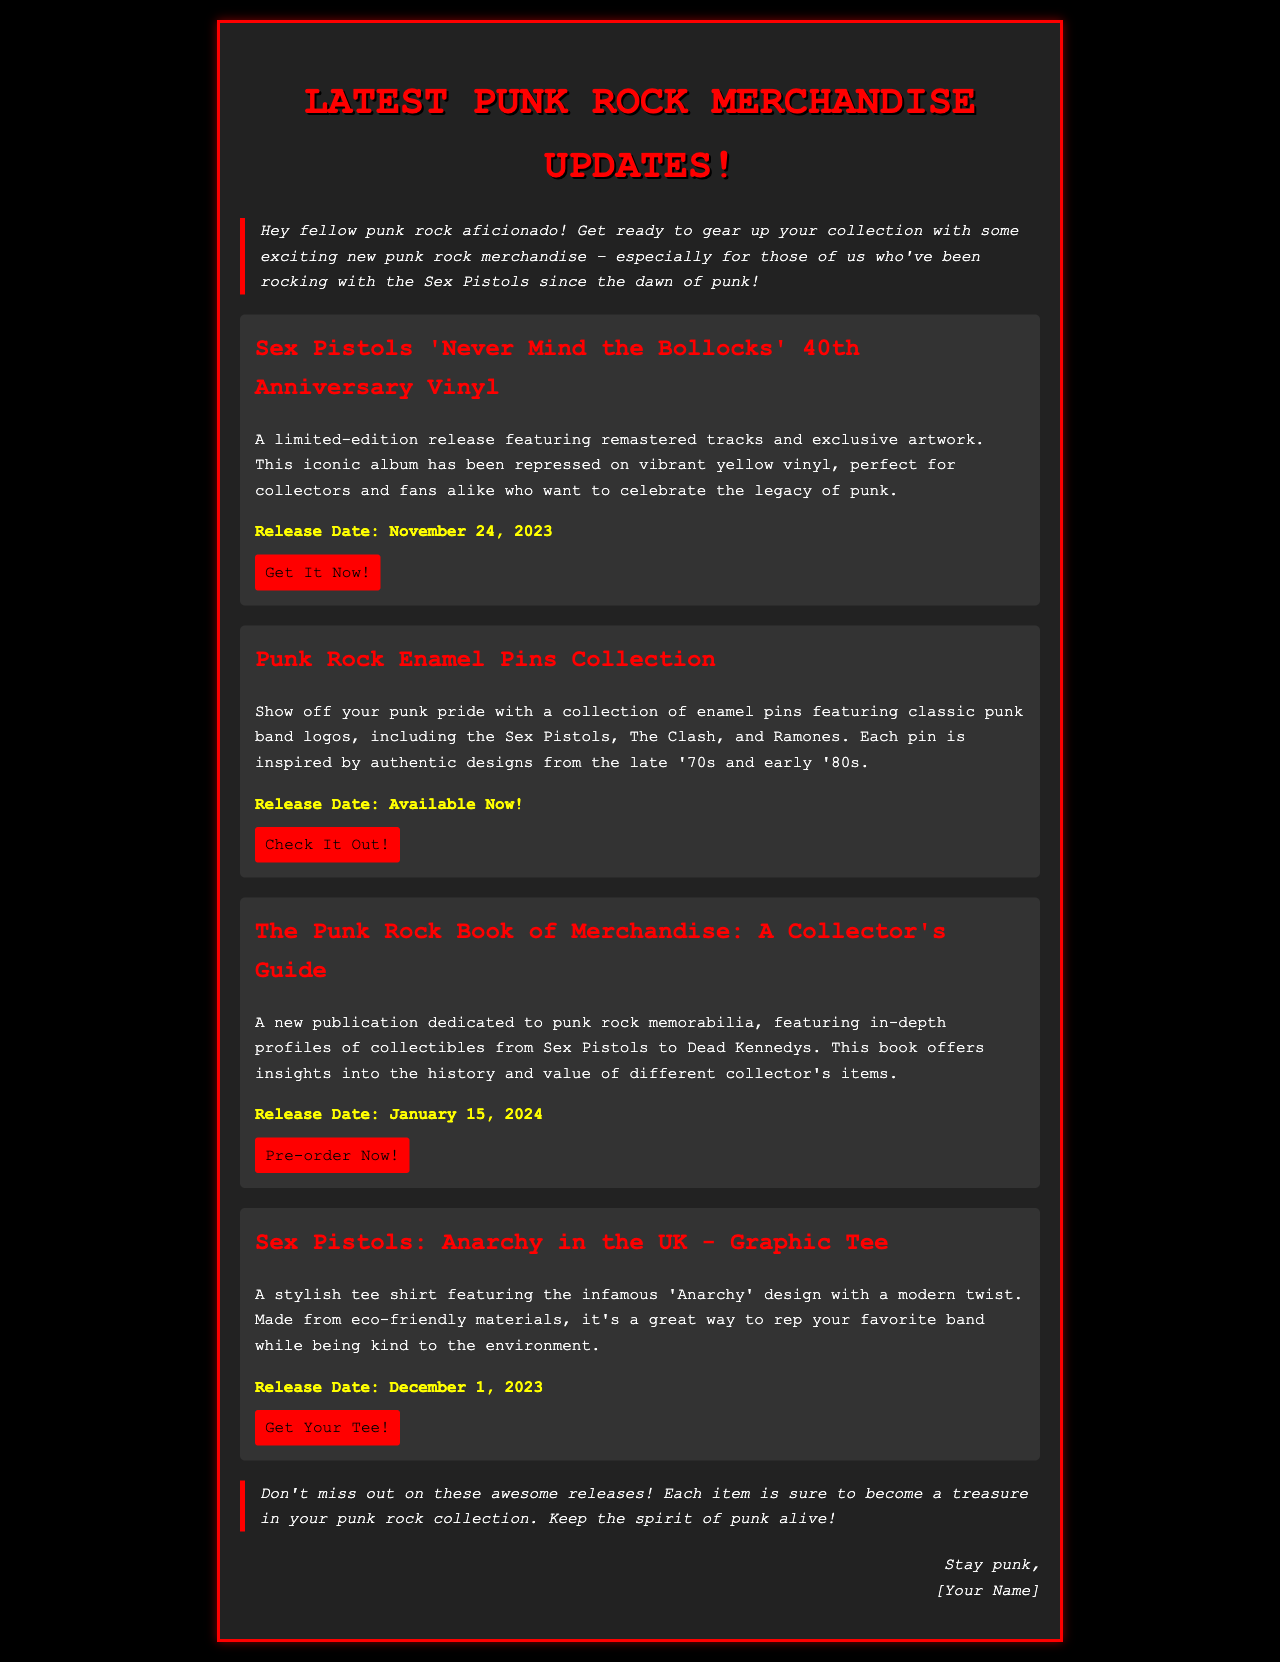What is the title of the latest vinyl release? The title of the latest vinyl release is "Sex Pistols 'Never Mind the Bollocks' 40th Anniversary Vinyl."
Answer: Sex Pistols 'Never Mind the Bollocks' 40th Anniversary Vinyl When is the release date for the graphic tee? The release date for the graphic tee is mentioned in the document.
Answer: December 1, 2023 What color is the vinyl for the 40th Anniversary release? The document specifies the color of the vinyl for the 40th Anniversary release.
Answer: Yellow What item features classic punk band logos? The item that features classic punk band logos is described in the document.
Answer: Punk Rock Enamel Pins Collection What is the release date of the collector's guide book? The document provides the release date of the collector's guide book.
Answer: January 15, 2024 Which item is available for immediate purchase? The document indicates which item is available for immediate purchase.
Answer: Punk Rock Enamel Pins Collection What type of merchandise is included in the punk rock update? The document includes several types of punk rock merchandise.
Answer: Vinyl records and collector's items Who is the signature line addressed to? The signature line in the document indicates the intended recipient.
Answer: [Your Name] 